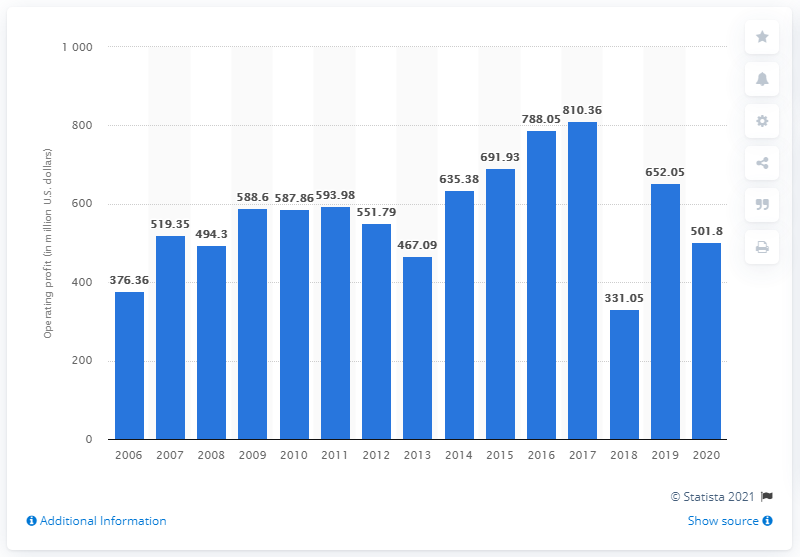Mention a couple of crucial points in this snapshot. In 2020, Hasbro's operating profit was 501.8 million dollars. 